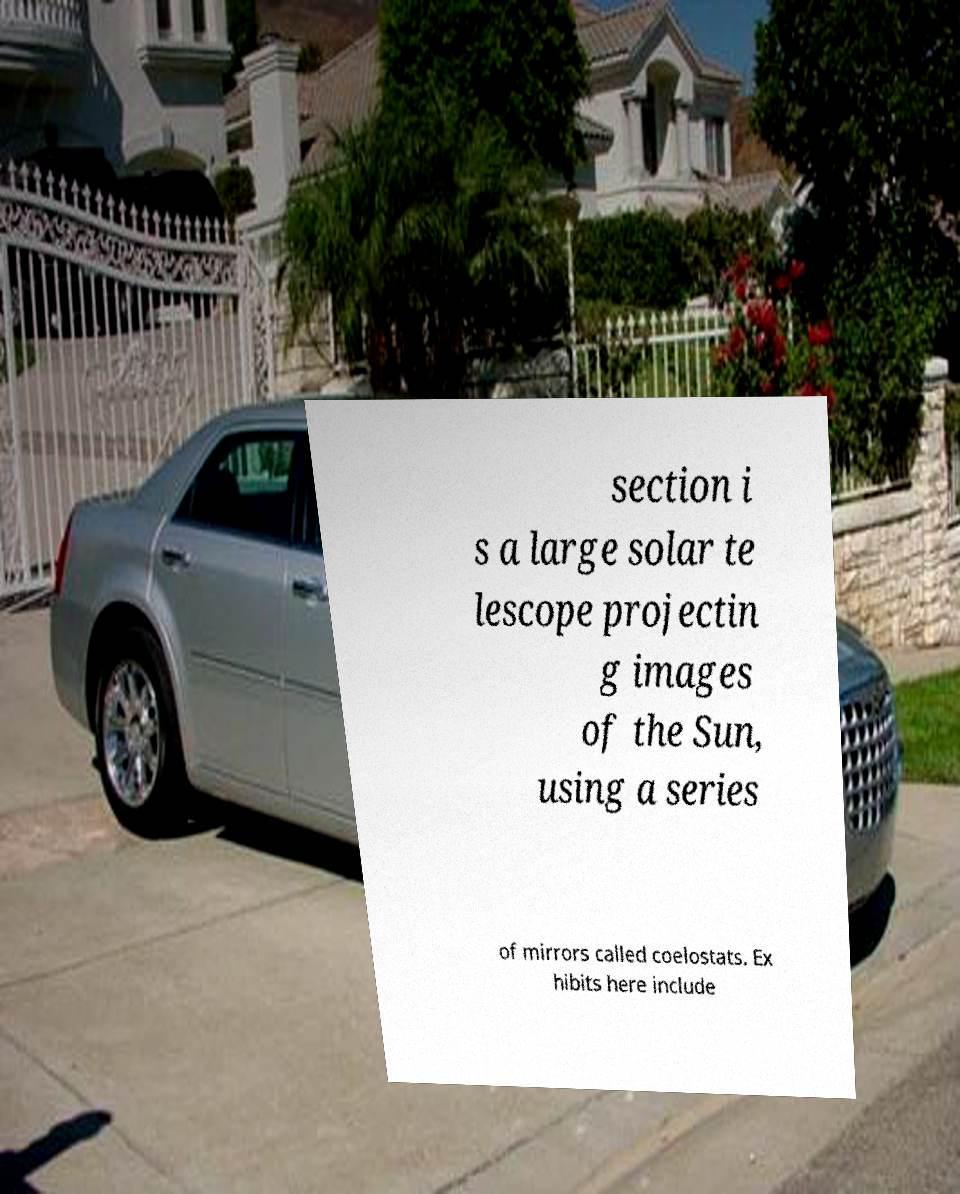Can you read and provide the text displayed in the image?This photo seems to have some interesting text. Can you extract and type it out for me? section i s a large solar te lescope projectin g images of the Sun, using a series of mirrors called coelostats. Ex hibits here include 